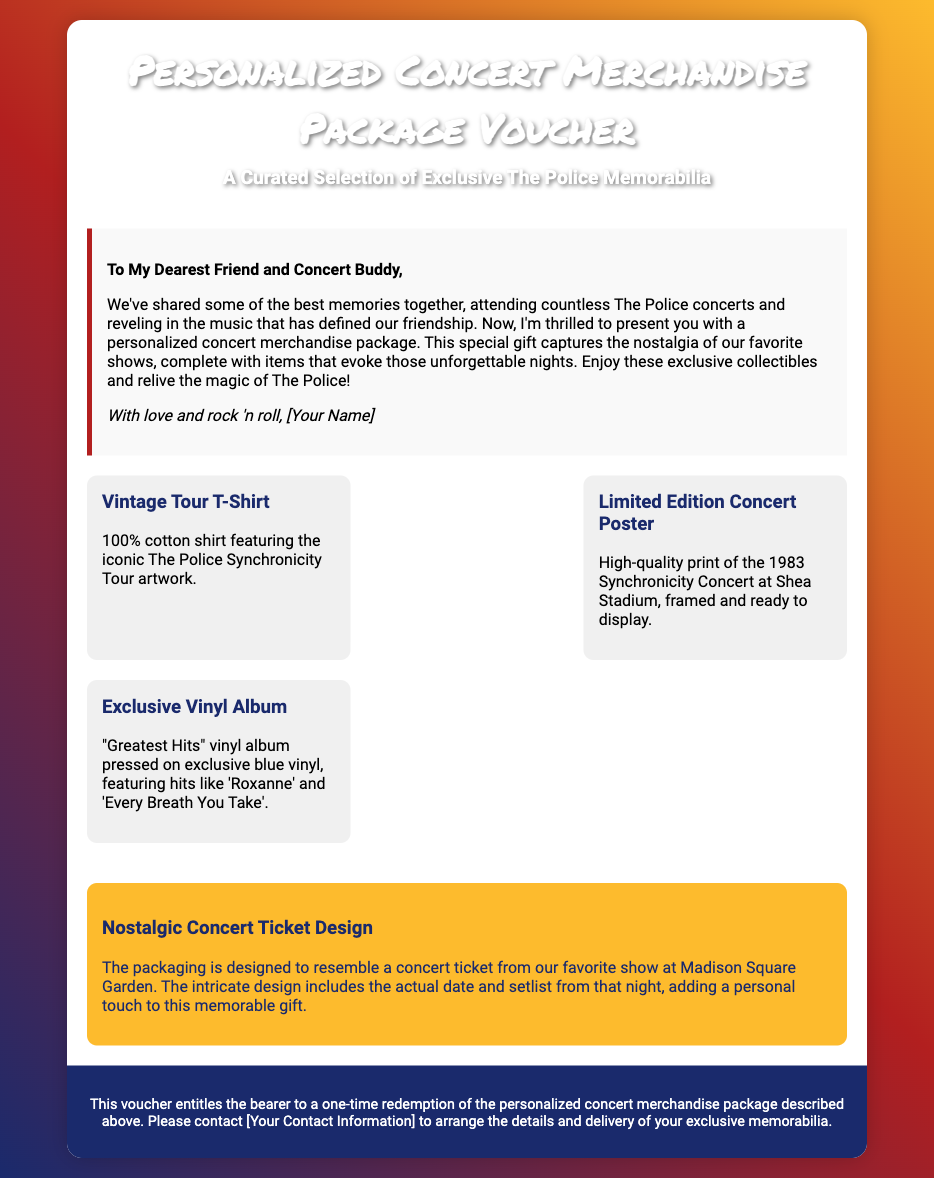What is the title of the voucher? The title is prominently featured at the top of the document as the main heading.
Answer: Personalized Concert Merchandise Package Voucher Who is the message addressed to? The message is specifically directed to a person who shares concert memories, indicating a close relationship.
Answer: My Dearest Friend and Concert Buddy What kind of T-shirt is included in the package? The document describes the T-shirt's material and design, detailing its association with a specific tour.
Answer: Vintage Tour T-Shirt What year was the concert poster from? The document provides details about the concert poster, including the year of the performance referenced.
Answer: 1983 What color is the exclusive vinyl album? The vinyl album is described in the document, including its exclusive color which stands out.
Answer: Blue How is the packaging designed? The design details provided in the document describe a specific aspect of the merchandise package.
Answer: Concert ticket design What is the quality of the concert poster? The document specifies the type of print and condition of the concert poster included in the merchandise package.
Answer: High-quality print How can the bearer redeem the voucher? The document outlines the procedure for using the voucher, highlighting the necessary action needed from the holder.
Answer: Contact [Your Contact Information] 